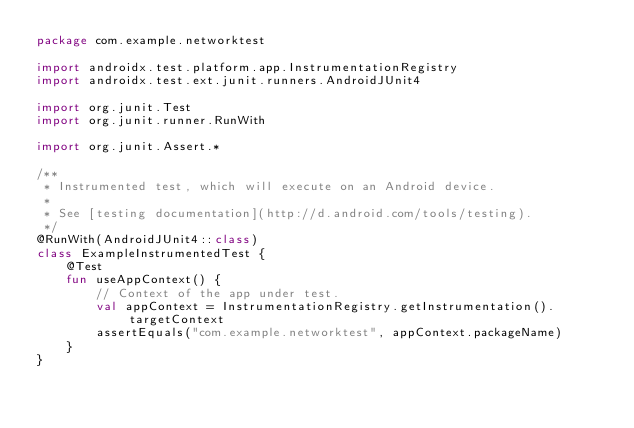Convert code to text. <code><loc_0><loc_0><loc_500><loc_500><_Kotlin_>package com.example.networktest

import androidx.test.platform.app.InstrumentationRegistry
import androidx.test.ext.junit.runners.AndroidJUnit4

import org.junit.Test
import org.junit.runner.RunWith

import org.junit.Assert.*

/**
 * Instrumented test, which will execute on an Android device.
 *
 * See [testing documentation](http://d.android.com/tools/testing).
 */
@RunWith(AndroidJUnit4::class)
class ExampleInstrumentedTest {
    @Test
    fun useAppContext() {
        // Context of the app under test.
        val appContext = InstrumentationRegistry.getInstrumentation().targetContext
        assertEquals("com.example.networktest", appContext.packageName)
    }
}</code> 